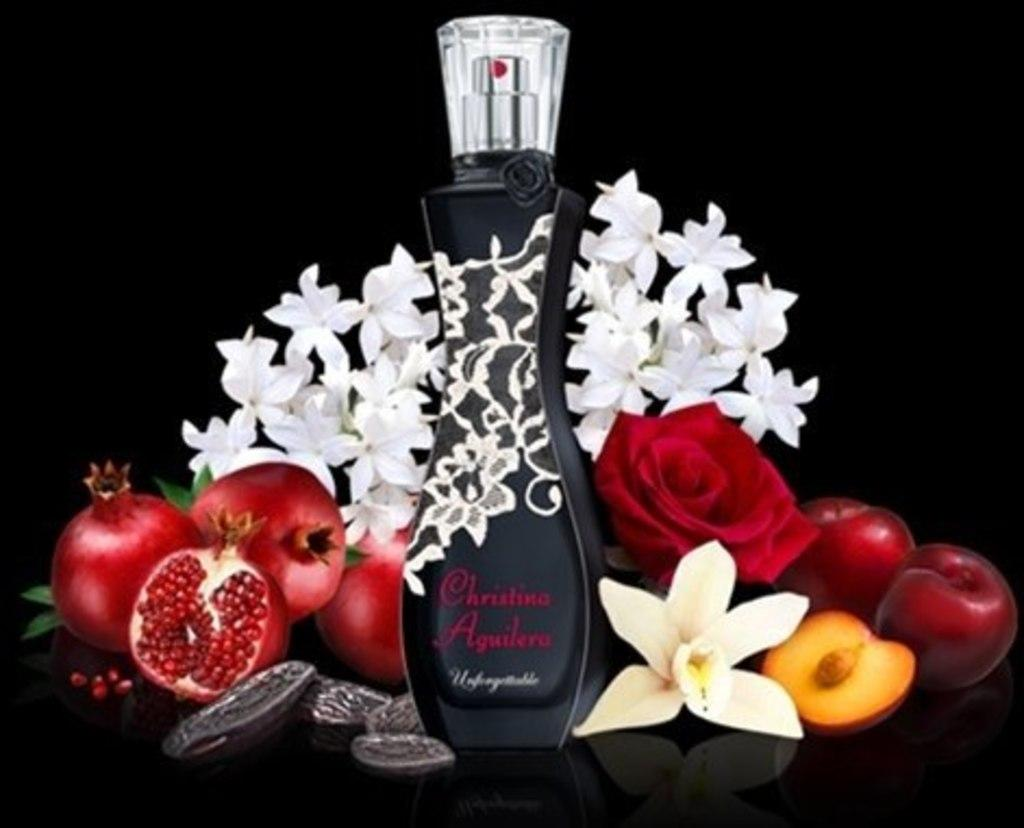<image>
Create a compact narrative representing the image presented. Black perfume bottle by Christina Aguilera with flowers and fruit 